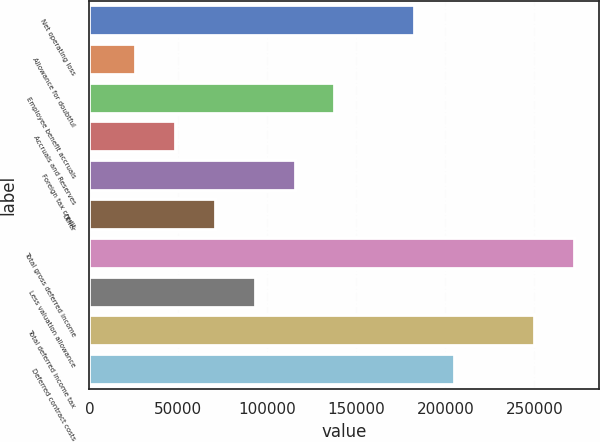Convert chart. <chart><loc_0><loc_0><loc_500><loc_500><bar_chart><fcel>Net operating loss<fcel>Allowance for doubtful<fcel>Employee benefit accruals<fcel>Accruals and Reserves<fcel>Foreign tax credit<fcel>Other<fcel>Total gross deferred income<fcel>Less valuation allowance<fcel>Total deferred income tax<fcel>Deferred contract costs<nl><fcel>183000<fcel>26154.5<fcel>138187<fcel>48561<fcel>115780<fcel>70967.5<fcel>272626<fcel>93374<fcel>250220<fcel>205406<nl></chart> 